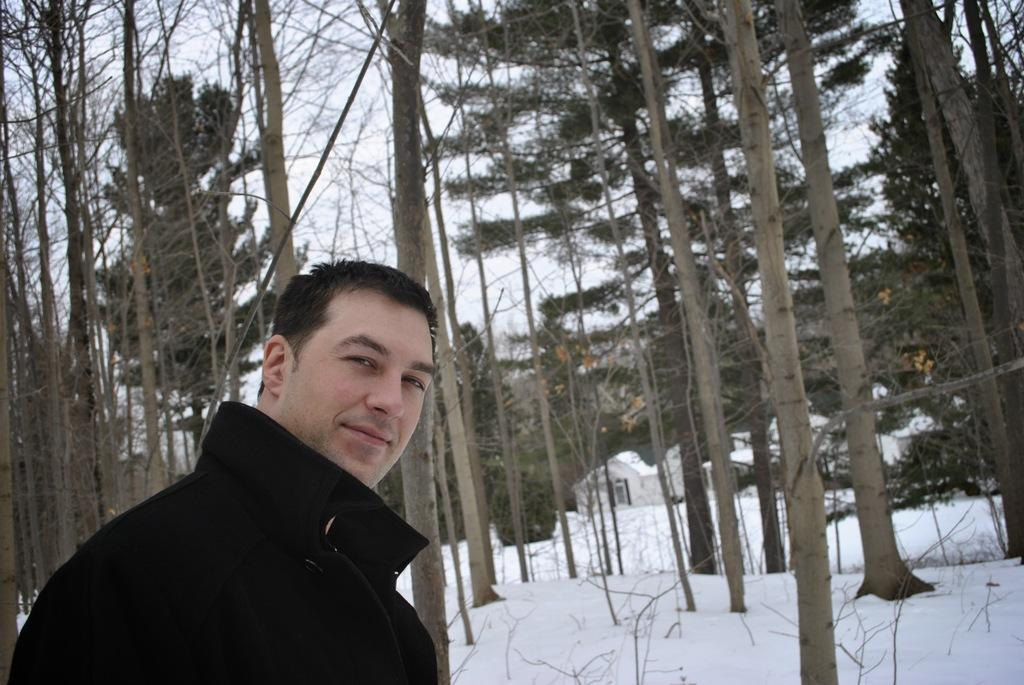Who is present in the image? There is a person in the image. What is the person wearing? The person is wearing a coat. What can be seen in the background of the image? There are trees and sheds in the background of the image. What is the ground covered with at the bottom of the image? There is snow at the bottom of the image. What type of breakfast is being prepared in the field in the image? There is no field or breakfast preparation present in the image. 